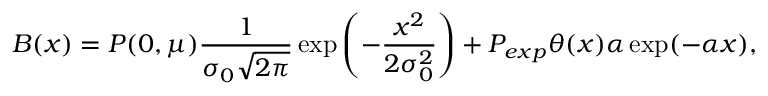<formula> <loc_0><loc_0><loc_500><loc_500>B ( x ) = P ( 0 , \mu ) \frac { 1 } { \sigma _ { 0 } \sqrt { 2 \pi } } \exp \left ( - \frac { x ^ { 2 } } { 2 \sigma _ { 0 } ^ { 2 } } \right ) + P _ { e x p } \theta ( x ) \alpha \exp ( - \alpha x ) ,</formula> 